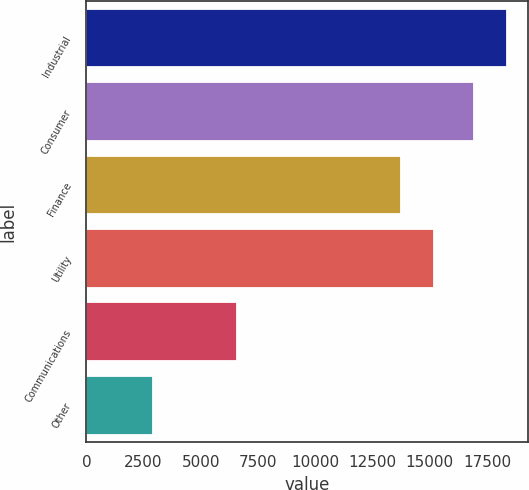<chart> <loc_0><loc_0><loc_500><loc_500><bar_chart><fcel>Industrial<fcel>Consumer<fcel>Finance<fcel>Utility<fcel>Communications<fcel>Other<nl><fcel>18359<fcel>16924<fcel>13756<fcel>15191<fcel>6580<fcel>2896<nl></chart> 